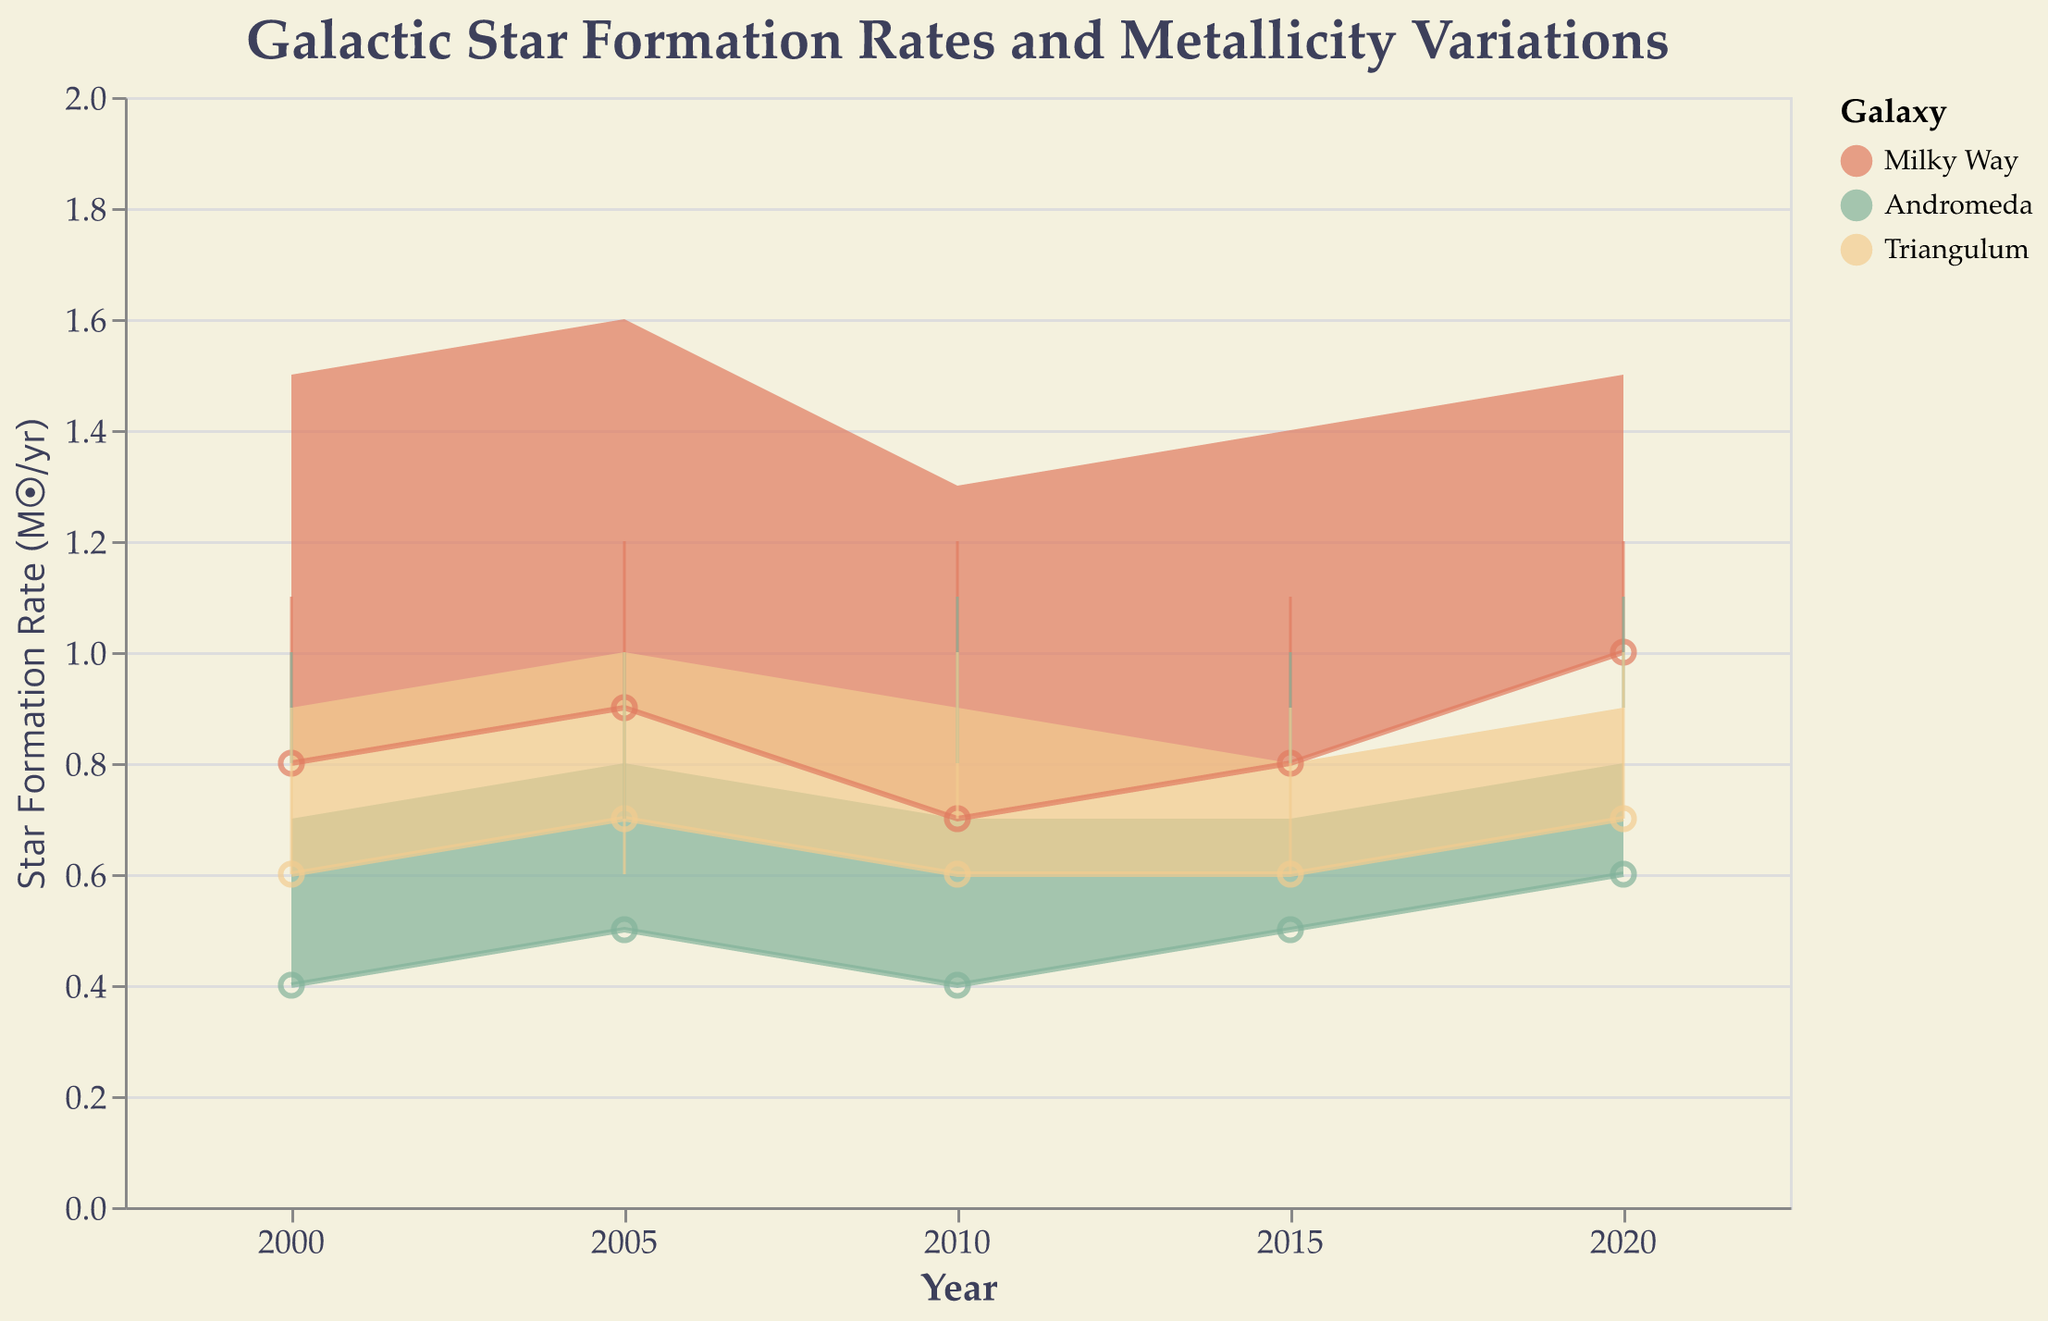What is the title of the chart? The title of the chart is displayed at the top and describes the topic of the visual representation.
Answer: Galactic Star Formation Rates and Metallicity Variations Which galaxy has the highest maximum star formation rate in 2020? The chart shows the star formation rates for different galaxies at various years. By comparing the data points for 2020, we can identify the galaxy with the highest upper value.
Answer: Milky Way Among the three galaxies, which one shows the smallest range in star formation rate in 2005? By comparing the difference between the minimum and maximum star formation rates shown in 2005 for each galaxy, we can determine which one has the smallest range.
Answer: Andromeda What are the metallicity range values for the Milky Way in 2010? The metallicity range is shown with vertical lines (rules) for each galaxy and year. By looking at the 2010 data for the Milky Way, we can observe the minimum and maximum values.
Answer: 1.0 to 1.2 How does the Triangulum galaxy's range in metallicity change from 2000 to 2020? By comparing the metallicity range (the difference between maximum and minimum values) for the Triangulum galaxy at the years 2000 and 2020, we can observe how it changes.
Answer: In 2000, it ranges from 0.6 to 0.9, and in 2020, it ranges from 0.7 to 1.0 Which galaxy shows the most significant increase in its maximum star formation rate from 2015 to 2020? By looking at the difference in the maximum star formation rates between 2015 and 2020 for each galaxy, we can find which one has the largest increase.
Answer: Milky Way What is the average minimum star formation rate of Andromeda over the entire period? To find the average minimum star formation rate, we sum the minimum values across all years (0.4, 0.5, 0.4, 0.5, 0.6) and divide by the number of years (5).
Answer: 0.48 Compare the metallicity ranges of the Milky Way and Andromeda in 2005. Which is larger? By examining the metallicity ranges for both galaxies in 2005 (the difference between max and min values) and comparing them, we determine which galaxy has a larger range. Milky Way: 0.9-1.2 = 0.3, Andromeda: 0.7-1.0 = 0.3
Answer: They are the same In which year does the Milky Way have the smallest range in star formation rate? The star formation ranges are represented by the area between the minimum and maximum values. By comparing these ranges across all years for the Milky Way, we identify the smallest one.
Answer: 2010 In 2020, which galaxy has the narrowest metallicity range, and what is the value? By visually inspecting the metallicity ranges for each galaxy in 2020, we can determine the narrowest range and its value.
Answer: Andromeda, 0.9 to 1.1 (0.2) 